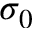<formula> <loc_0><loc_0><loc_500><loc_500>\sigma _ { 0 }</formula> 